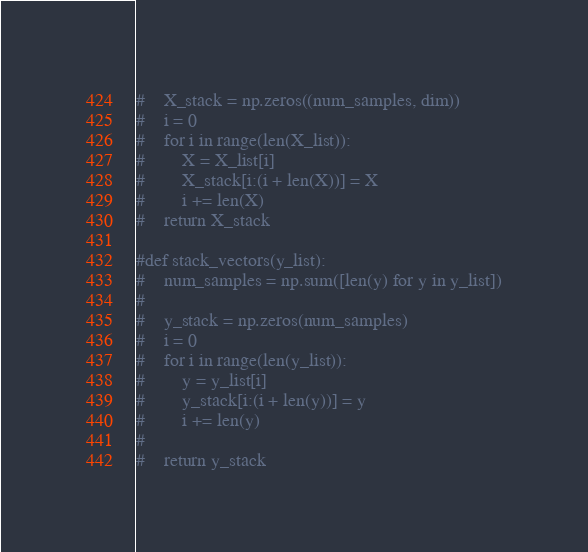<code> <loc_0><loc_0><loc_500><loc_500><_Python_>#    X_stack = np.zeros((num_samples, dim))
#    i = 0
#    for i in range(len(X_list)):
#        X = X_list[i]
#        X_stack[i:(i + len(X))] = X
#        i += len(X)
#    return X_stack

#def stack_vectors(y_list):
#    num_samples = np.sum([len(y) for y in y_list])
#    
#    y_stack = np.zeros(num_samples)
#    i = 0
#    for i in range(len(y_list)):
#        y = y_list[i]
#        y_stack[i:(i + len(y))] = y
#        i += len(y)
#        
#    return y_stack
</code> 